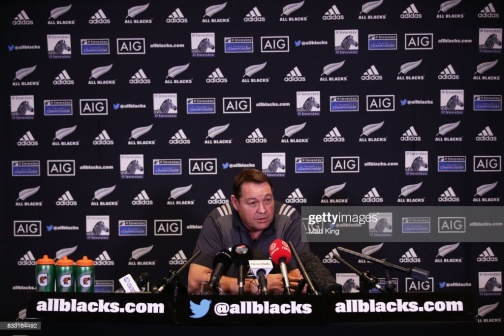From the image, imagine a very creative context about the event. Imagine that the scene is set in an alternate reality where the All Blacks are not just a rugby team, but peacekeeping warriors known across the galaxy. The man at the desk is their commander, reporting on their latest mission to unite warring planets through the universal language of sport. Behind him, holographic logos of their sponsors, who are influential galactic corporations, hover in mid-air. He's discussing the recent interplanetary tournament, where winning teams gain not only glory but also negotiate peace treaties. The commander talks about the challenges faced, such as navigating zero-gravity tackles and playing matches on planets with extreme climates. His detailed account captures the imagination of all present, illustrating a narrative where sport transcends mere games and becomes a tool for galactic harmony. 